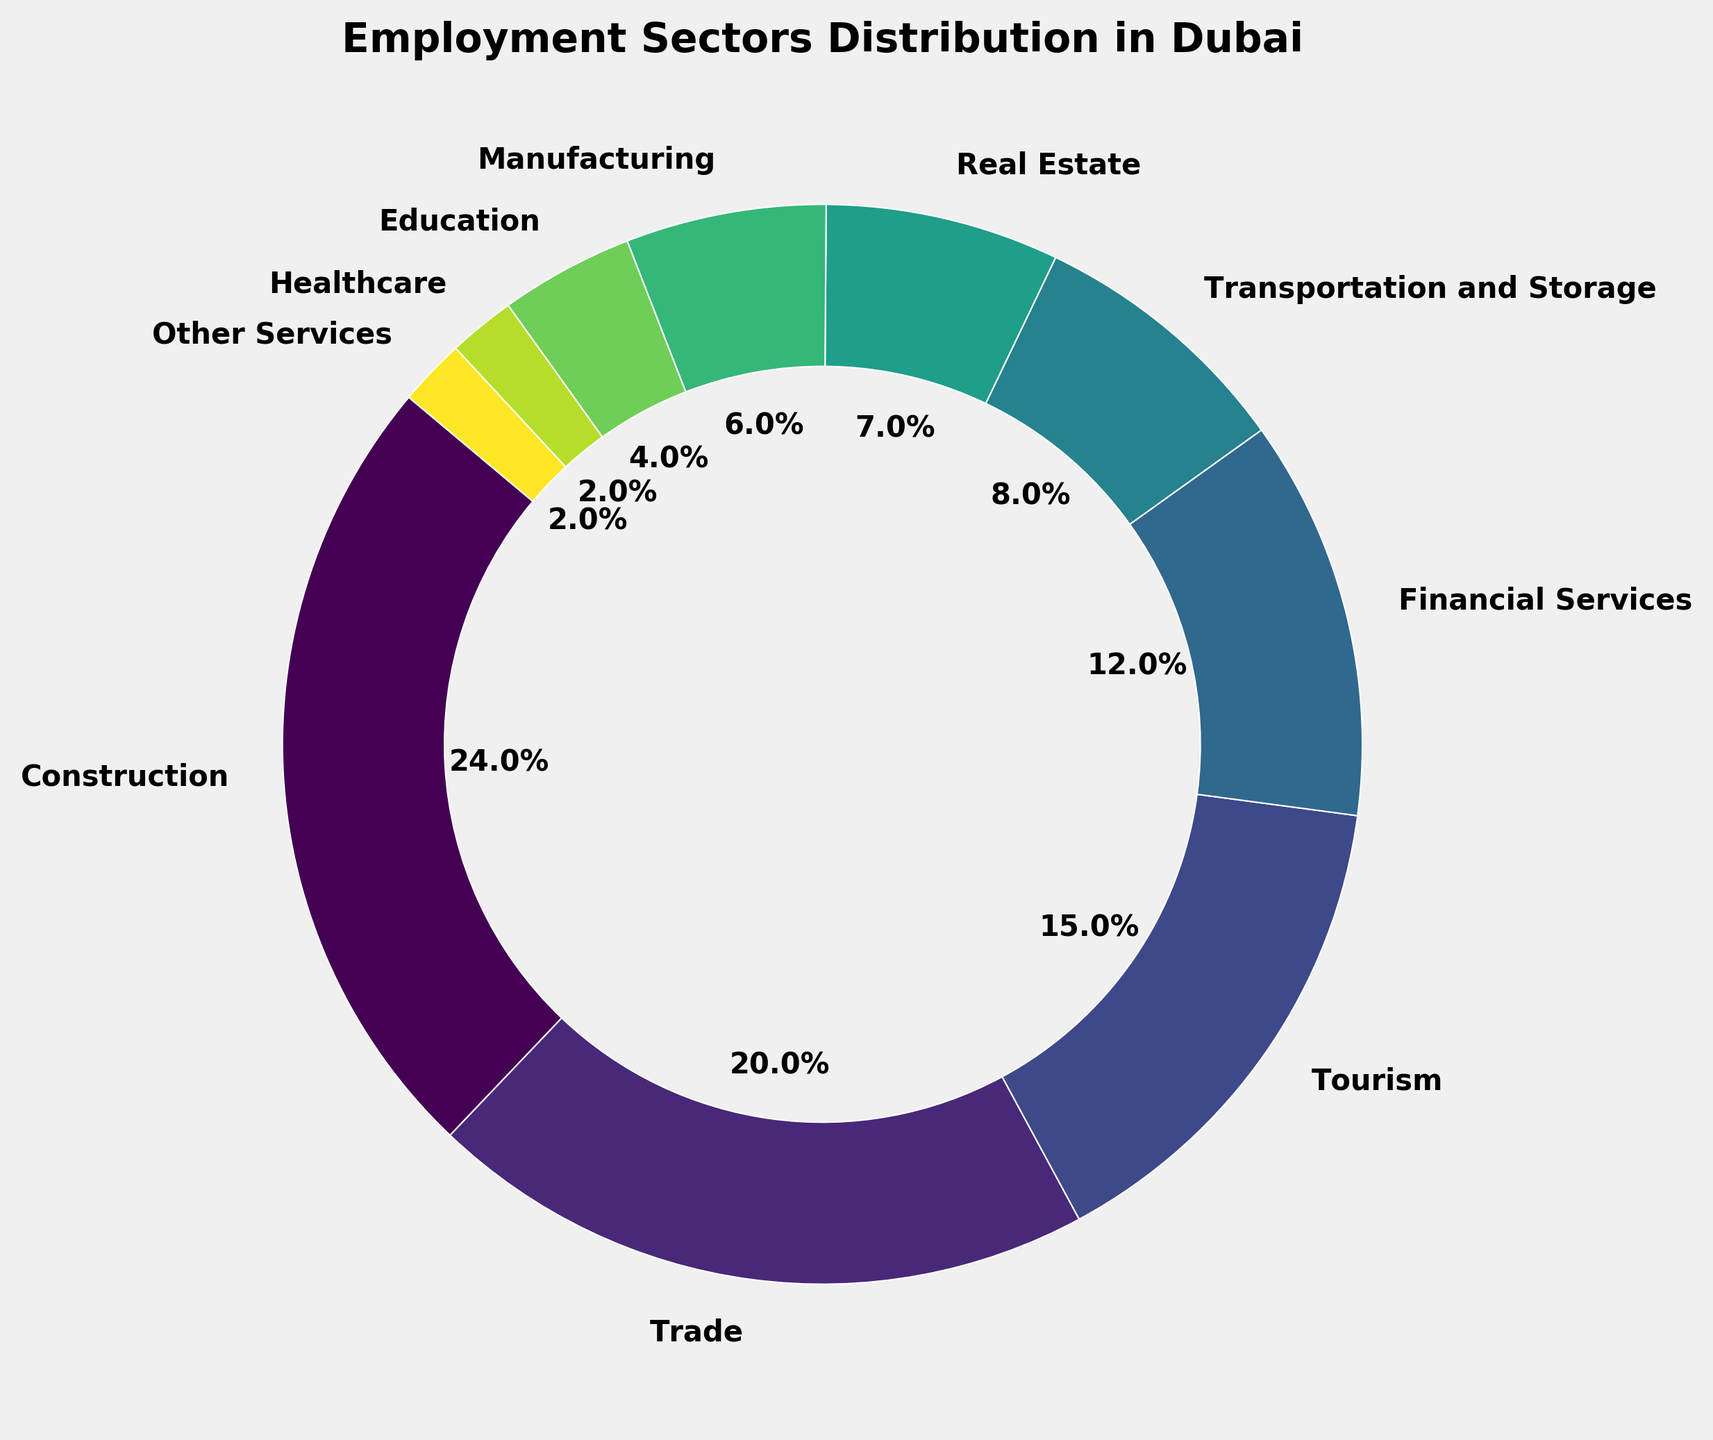What percentage of the working population is employed in the Healthcare and Other Services sectors combined? Add the percentages of the Healthcare sector (2%) and the Other Services sector (2%) together.
Answer: 4% Which sector employs the largest percentage of the working population? By visual inspection, the Construction sector has the largest slice of the pie chart, which corresponds to the highest percentage.
Answer: Construction What is the difference in employment percentages between the Trade and Manufacturing sectors? Subtract the percentage of the Manufacturing sector (6%) from the percentage of the Trade sector (20%).
Answer: 14% Which sector employs more people: Financial Services or Real Estate? Compare the percentages of Financial Services (12%) and Real Estate (7%). Financial Services has a higher percentage.
Answer: Financial Services What is the sum of the percentages for the Education, Healthcare, and Other Services sectors? Add the percentages of the Education (4%), Healthcare (2%), and Other Services (2%) sectors.
Answer: 8% How much higher is the employment percentage in Financial Services compared to Tourism? Subtract the percentage of Tourism (15%) from the percentage of Financial Services (12%).
Answer: -3% Which sectors have less than 10% of employment but more than 5%? Identify sectors between 5% and 10%. These are Transportation and Storage (8%), Real Estate (7%), and Manufacturing (6%).
Answer: Transportation and Storage, Real Estate, and Manufacturing What is the combined percentage of the top three employment sectors? Add the percentages of the Construction (24%), Trade (20%), and Tourism (15%) sectors.
Answer: 59% Are there any sectors with equal employment percentages? Compare the percentages of all sectors. Healthcare and Other Services both have 2%.
Answer: Healthcare and Other Services What is the percentage difference between the sector with the highest employment and the sector with the lowest employment? Subtract the percentage of the lowest sector (2%) from the highest sector (24%).
Answer: 22% 